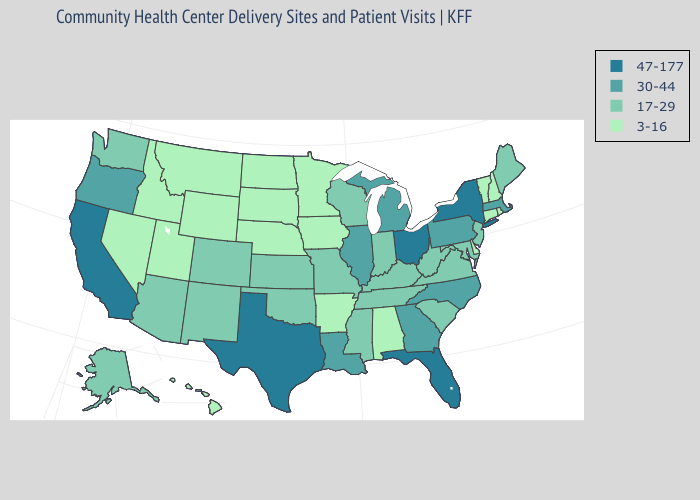How many symbols are there in the legend?
Give a very brief answer. 4. Name the states that have a value in the range 30-44?
Concise answer only. Georgia, Illinois, Louisiana, Massachusetts, Michigan, North Carolina, Oregon, Pennsylvania. Does the map have missing data?
Write a very short answer. No. Name the states that have a value in the range 30-44?
Concise answer only. Georgia, Illinois, Louisiana, Massachusetts, Michigan, North Carolina, Oregon, Pennsylvania. Which states have the lowest value in the USA?
Give a very brief answer. Alabama, Arkansas, Connecticut, Delaware, Hawaii, Idaho, Iowa, Minnesota, Montana, Nebraska, Nevada, New Hampshire, North Dakota, Rhode Island, South Dakota, Utah, Vermont, Wyoming. Name the states that have a value in the range 47-177?
Be succinct. California, Florida, New York, Ohio, Texas. Which states have the lowest value in the USA?
Quick response, please. Alabama, Arkansas, Connecticut, Delaware, Hawaii, Idaho, Iowa, Minnesota, Montana, Nebraska, Nevada, New Hampshire, North Dakota, Rhode Island, South Dakota, Utah, Vermont, Wyoming. Does North Carolina have the lowest value in the South?
Quick response, please. No. Does Montana have the lowest value in the West?
Quick response, please. Yes. What is the lowest value in the USA?
Short answer required. 3-16. Does Iowa have the highest value in the MidWest?
Give a very brief answer. No. Which states have the highest value in the USA?
Keep it brief. California, Florida, New York, Ohio, Texas. How many symbols are there in the legend?
Short answer required. 4. What is the value of Rhode Island?
Be succinct. 3-16. Among the states that border Delaware , does Pennsylvania have the highest value?
Be succinct. Yes. 